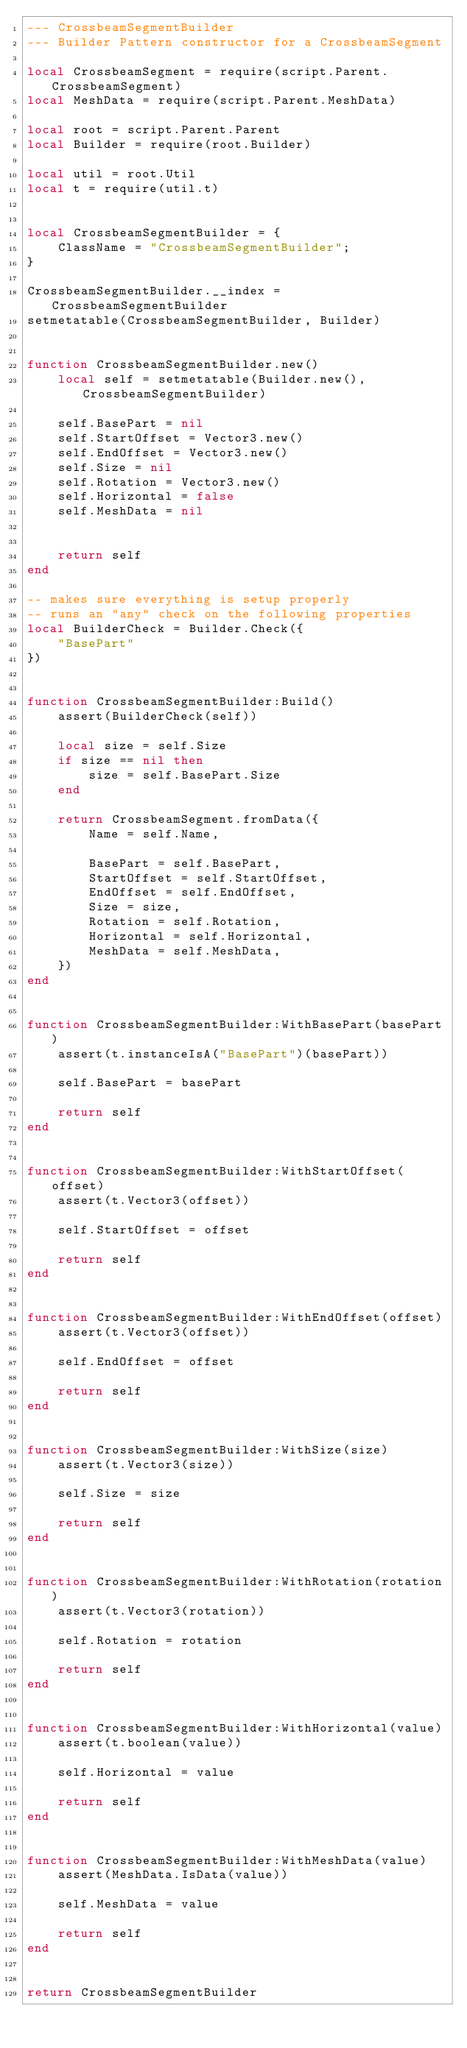<code> <loc_0><loc_0><loc_500><loc_500><_Lua_>--- CrossbeamSegmentBuilder
--- Builder Pattern constructor for a CrossbeamSegment

local CrossbeamSegment = require(script.Parent.CrossbeamSegment)
local MeshData = require(script.Parent.MeshData)

local root = script.Parent.Parent
local Builder = require(root.Builder)

local util = root.Util
local t = require(util.t)


local CrossbeamSegmentBuilder = {
	ClassName = "CrossbeamSegmentBuilder";
}

CrossbeamSegmentBuilder.__index = CrossbeamSegmentBuilder
setmetatable(CrossbeamSegmentBuilder, Builder)


function CrossbeamSegmentBuilder.new()
	local self = setmetatable(Builder.new(), CrossbeamSegmentBuilder)

	self.BasePart = nil
	self.StartOffset = Vector3.new()
	self.EndOffset = Vector3.new()
	self.Size = nil
	self.Rotation = Vector3.new()
	self.Horizontal = false
	self.MeshData = nil


	return self
end

-- makes sure everything is setup properly
-- runs an "any" check on the following properties
local BuilderCheck = Builder.Check({
	"BasePart"
})


function CrossbeamSegmentBuilder:Build()
	assert(BuilderCheck(self))

	local size = self.Size
	if size == nil then
		size = self.BasePart.Size
	end

	return CrossbeamSegment.fromData({
		Name = self.Name,

		BasePart = self.BasePart,
		StartOffset = self.StartOffset,
		EndOffset = self.EndOffset,
		Size = size,
		Rotation = self.Rotation,
		Horizontal = self.Horizontal,
		MeshData = self.MeshData,
	})
end


function CrossbeamSegmentBuilder:WithBasePart(basePart)
	assert(t.instanceIsA("BasePart")(basePart))

	self.BasePart = basePart

	return self
end


function CrossbeamSegmentBuilder:WithStartOffset(offset)
	assert(t.Vector3(offset))

	self.StartOffset = offset

	return self
end


function CrossbeamSegmentBuilder:WithEndOffset(offset)
	assert(t.Vector3(offset))

	self.EndOffset = offset

	return self
end


function CrossbeamSegmentBuilder:WithSize(size)
	assert(t.Vector3(size))

	self.Size = size

	return self
end


function CrossbeamSegmentBuilder:WithRotation(rotation)
	assert(t.Vector3(rotation))

	self.Rotation = rotation

	return self
end


function CrossbeamSegmentBuilder:WithHorizontal(value)
	assert(t.boolean(value))

	self.Horizontal = value

	return self
end


function CrossbeamSegmentBuilder:WithMeshData(value)
	assert(MeshData.IsData(value))

	self.MeshData = value

	return self
end


return CrossbeamSegmentBuilder</code> 